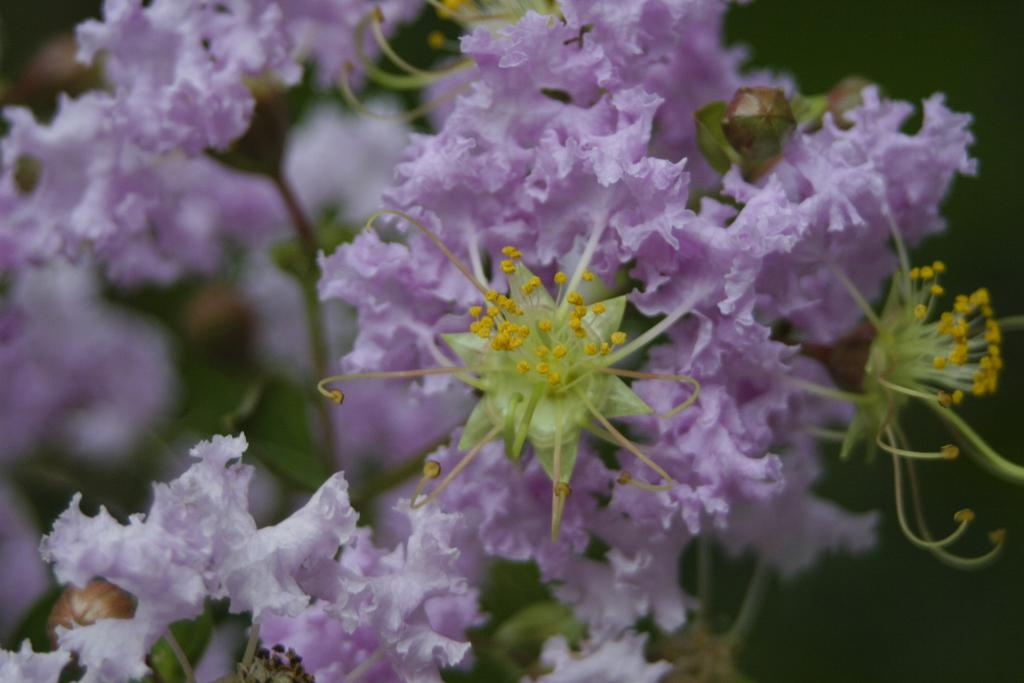What color are the flowers in the image? The flowers in the image are purple. What can be found in the center of the flowers? There are pollen grains in yellow color in the middle of the flowers. How would you describe the background of the image? The background of the image is blurred. What type of bun is being used to hold the flowers together in the image? There is no bun present in the image; the flowers are not held together by any external object. 